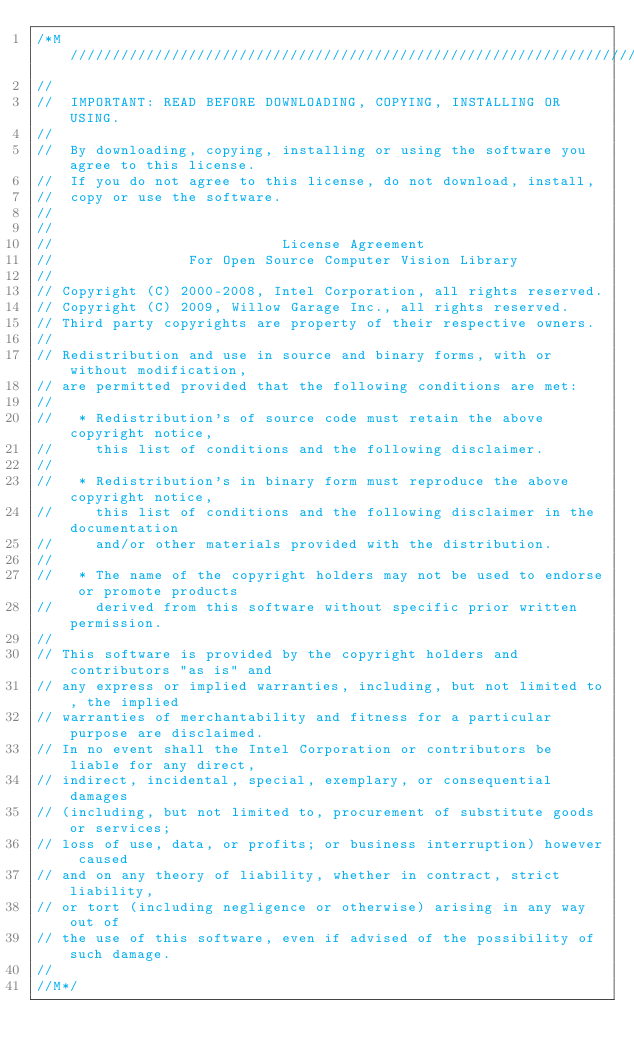<code> <loc_0><loc_0><loc_500><loc_500><_Cuda_>/*M///////////////////////////////////////////////////////////////////////////////////////
//
//  IMPORTANT: READ BEFORE DOWNLOADING, COPYING, INSTALLING OR USING.
//
//  By downloading, copying, installing or using the software you agree to this license.
//  If you do not agree to this license, do not download, install,
//  copy or use the software.
//
//
//                           License Agreement
//                For Open Source Computer Vision Library
//
// Copyright (C) 2000-2008, Intel Corporation, all rights reserved.
// Copyright (C) 2009, Willow Garage Inc., all rights reserved.
// Third party copyrights are property of their respective owners.
//
// Redistribution and use in source and binary forms, with or without modification,
// are permitted provided that the following conditions are met:
//
//   * Redistribution's of source code must retain the above copyright notice,
//     this list of conditions and the following disclaimer.
//
//   * Redistribution's in binary form must reproduce the above copyright notice,
//     this list of conditions and the following disclaimer in the documentation
//     and/or other materials provided with the distribution.
//
//   * The name of the copyright holders may not be used to endorse or promote products
//     derived from this software without specific prior written permission.
//
// This software is provided by the copyright holders and contributors "as is" and
// any express or implied warranties, including, but not limited to, the implied
// warranties of merchantability and fitness for a particular purpose are disclaimed.
// In no event shall the Intel Corporation or contributors be liable for any direct,
// indirect, incidental, special, exemplary, or consequential damages
// (including, but not limited to, procurement of substitute goods or services;
// loss of use, data, or profits; or business interruption) however caused
// and on any theory of liability, whether in contract, strict liability,
// or tort (including negligence or otherwise) arising in any way out of
// the use of this software, even if advised of the possibility of such damage.
//
//M*/
</code> 